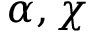Convert formula to latex. <formula><loc_0><loc_0><loc_500><loc_500>\alpha , \chi</formula> 